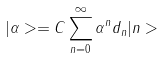Convert formula to latex. <formula><loc_0><loc_0><loc_500><loc_500>| \alpha > = C \sum _ { n = 0 } ^ { \infty } \alpha ^ { n } d _ { n } | n ></formula> 